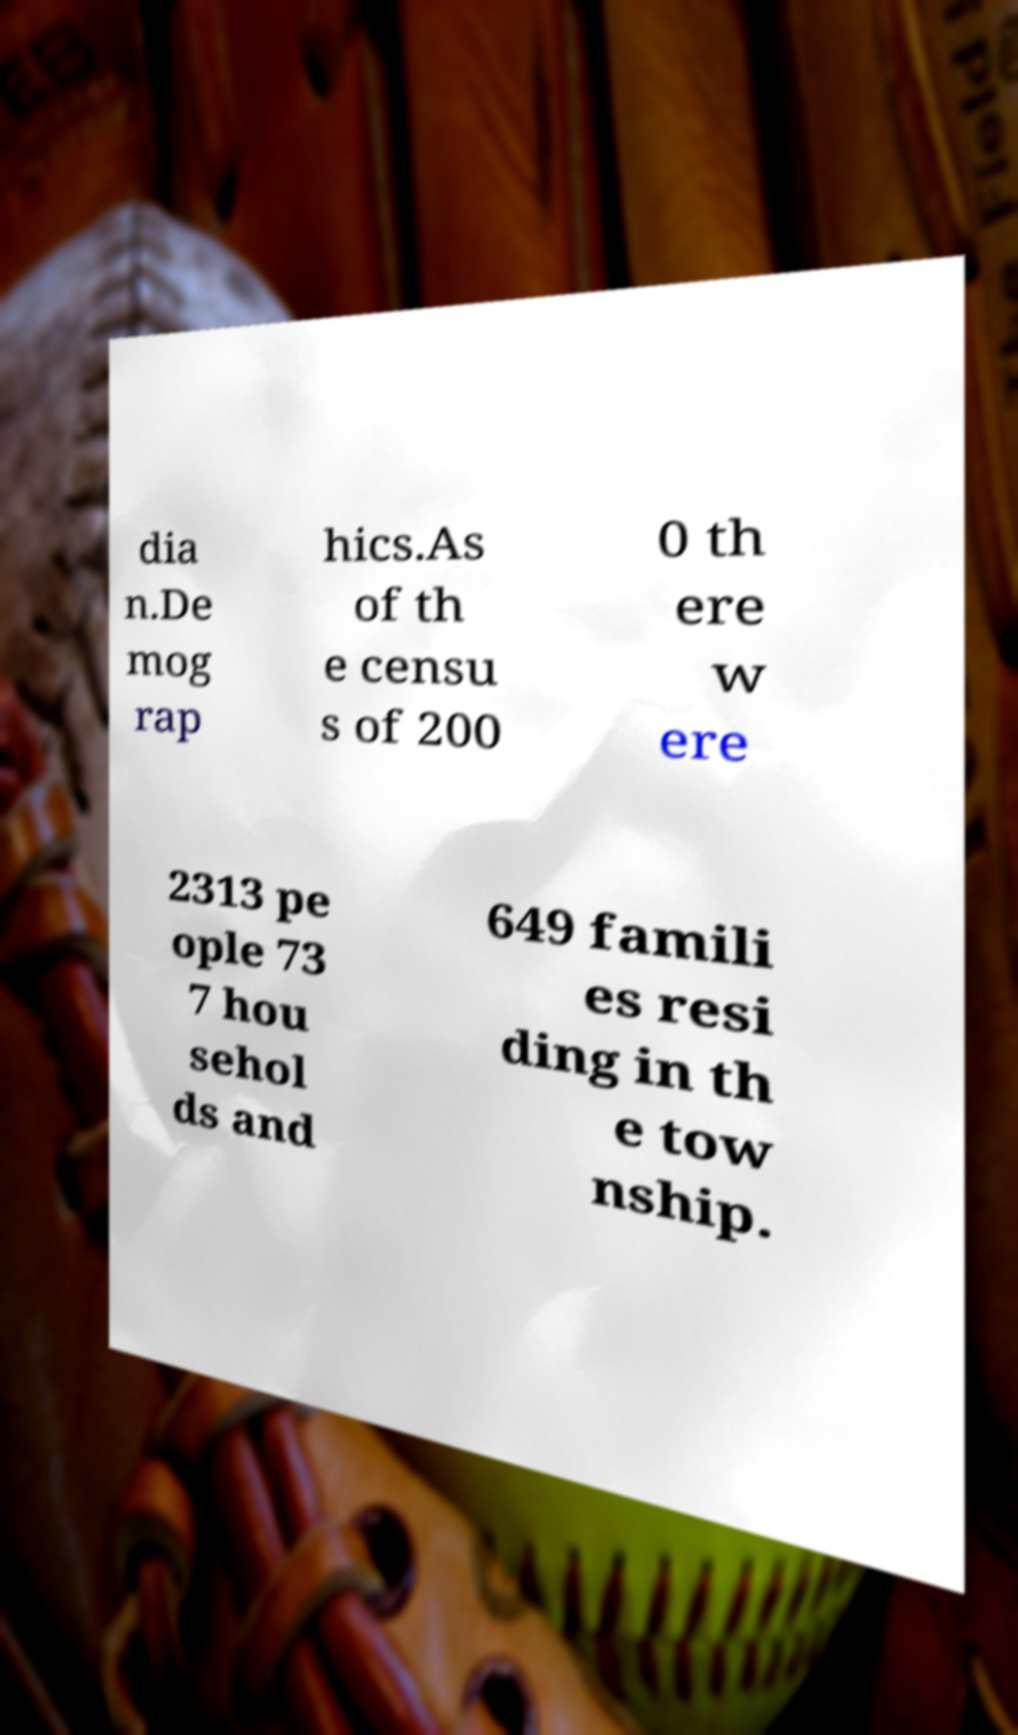Please read and relay the text visible in this image. What does it say? dia n.De mog rap hics.As of th e censu s of 200 0 th ere w ere 2313 pe ople 73 7 hou sehol ds and 649 famili es resi ding in th e tow nship. 